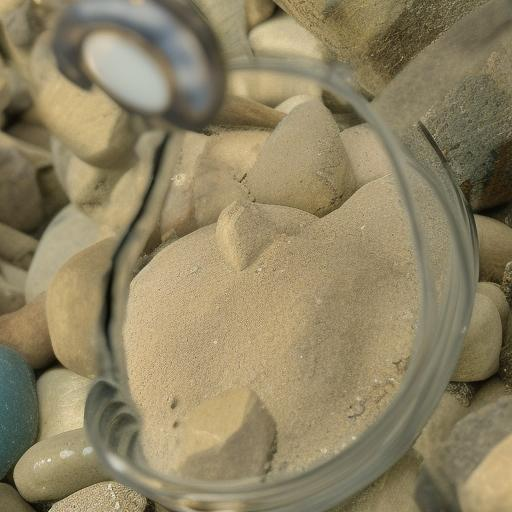How does the play of light and shadow contribute to the image's mood? The interplay of light and shadow in this image creates a serene and contemplative mood. The gentle illumination casts soft highlights on the sand and pebbles, emphasizing their textures and shapes. Those soft shadows add a sense of depth and dimension, inviting the viewer to reflect on the subtle complexities of natural forms. This can evoke a calming and meditative response, encouraging one to slow down and appreciate the delicate balance and harmony present in the scene. 